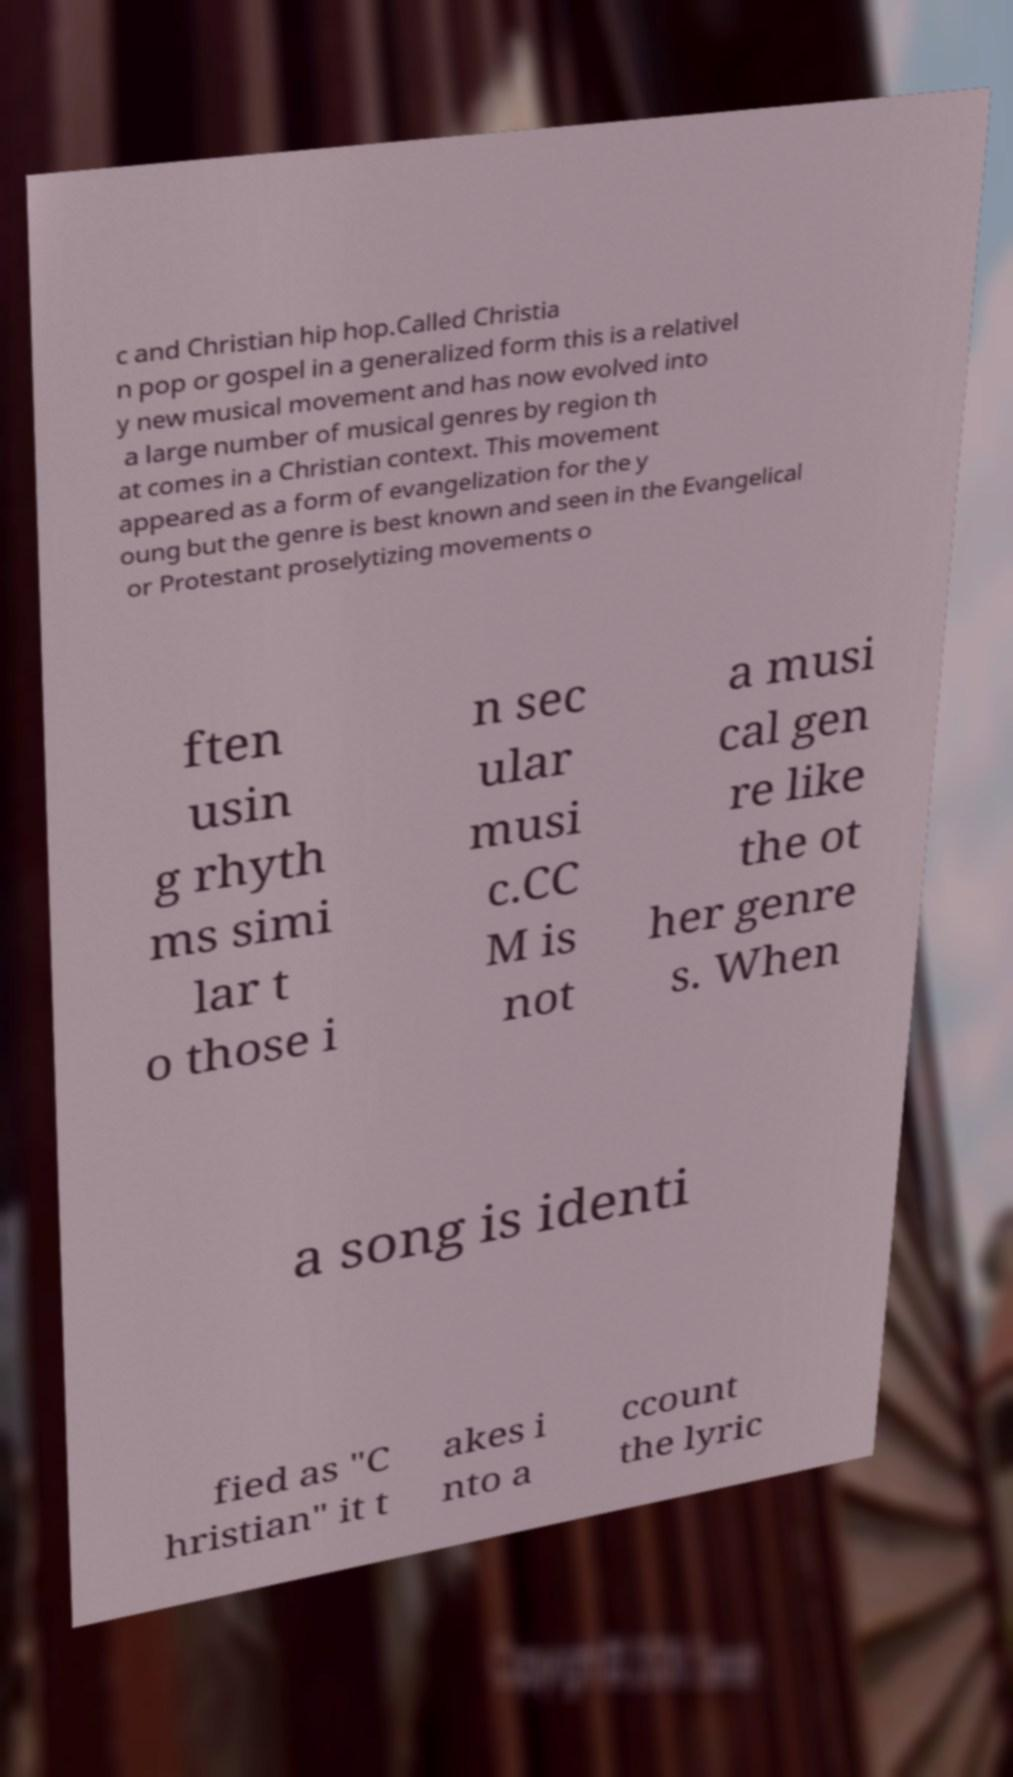Could you extract and type out the text from this image? c and Christian hip hop.Called Christia n pop or gospel in a generalized form this is a relativel y new musical movement and has now evolved into a large number of musical genres by region th at comes in a Christian context. This movement appeared as a form of evangelization for the y oung but the genre is best known and seen in the Evangelical or Protestant proselytizing movements o ften usin g rhyth ms simi lar t o those i n sec ular musi c.CC M is not a musi cal gen re like the ot her genre s. When a song is identi fied as "C hristian" it t akes i nto a ccount the lyric 